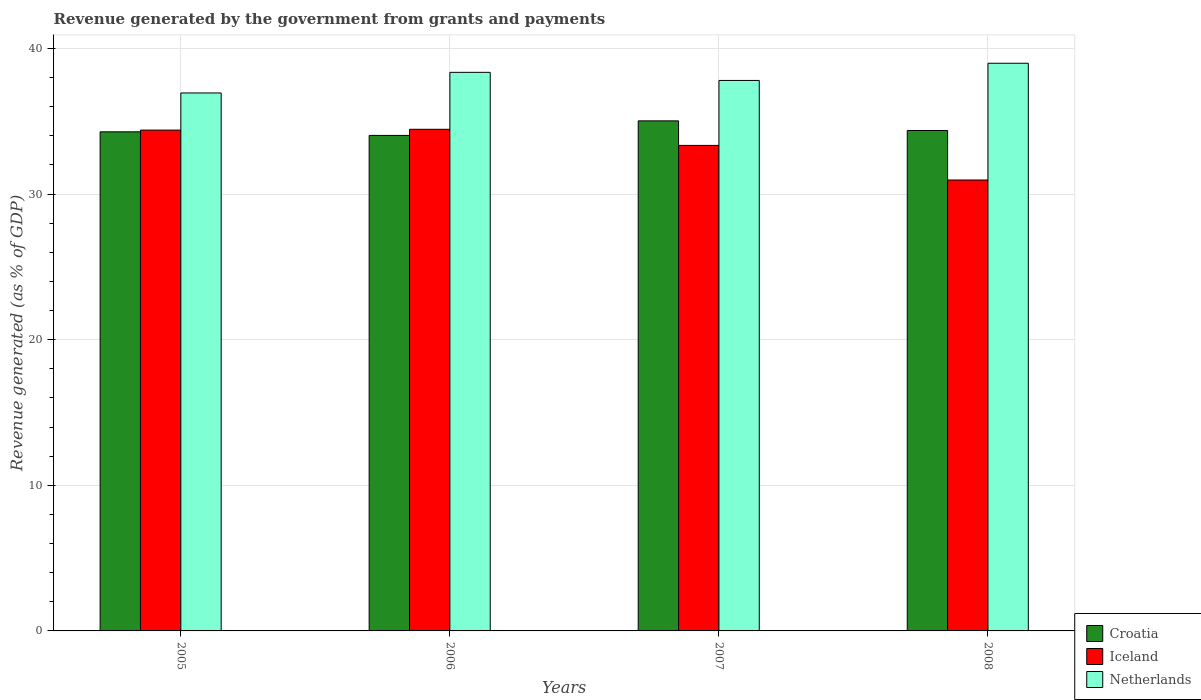How many groups of bars are there?
Offer a very short reply. 4. Are the number of bars per tick equal to the number of legend labels?
Provide a short and direct response. Yes. Are the number of bars on each tick of the X-axis equal?
Offer a terse response. Yes. How many bars are there on the 1st tick from the left?
Your response must be concise. 3. In how many cases, is the number of bars for a given year not equal to the number of legend labels?
Give a very brief answer. 0. What is the revenue generated by the government in Iceland in 2005?
Provide a succinct answer. 34.4. Across all years, what is the maximum revenue generated by the government in Netherlands?
Keep it short and to the point. 38.99. Across all years, what is the minimum revenue generated by the government in Iceland?
Offer a terse response. 30.97. In which year was the revenue generated by the government in Croatia minimum?
Give a very brief answer. 2006. What is the total revenue generated by the government in Croatia in the graph?
Offer a terse response. 137.71. What is the difference between the revenue generated by the government in Netherlands in 2006 and that in 2007?
Your response must be concise. 0.56. What is the difference between the revenue generated by the government in Netherlands in 2007 and the revenue generated by the government in Iceland in 2006?
Your response must be concise. 3.35. What is the average revenue generated by the government in Croatia per year?
Make the answer very short. 34.43. In the year 2007, what is the difference between the revenue generated by the government in Netherlands and revenue generated by the government in Iceland?
Offer a very short reply. 4.46. What is the ratio of the revenue generated by the government in Netherlands in 2006 to that in 2008?
Your answer should be very brief. 0.98. What is the difference between the highest and the second highest revenue generated by the government in Netherlands?
Make the answer very short. 0.62. What is the difference between the highest and the lowest revenue generated by the government in Croatia?
Your answer should be very brief. 1. Is the sum of the revenue generated by the government in Croatia in 2006 and 2007 greater than the maximum revenue generated by the government in Netherlands across all years?
Ensure brevity in your answer.  Yes. What does the 3rd bar from the right in 2007 represents?
Provide a succinct answer. Croatia. How many bars are there?
Your answer should be compact. 12. Are all the bars in the graph horizontal?
Keep it short and to the point. No. How many years are there in the graph?
Provide a succinct answer. 4. Are the values on the major ticks of Y-axis written in scientific E-notation?
Keep it short and to the point. No. Where does the legend appear in the graph?
Your answer should be very brief. Bottom right. What is the title of the graph?
Your response must be concise. Revenue generated by the government from grants and payments. Does "Lebanon" appear as one of the legend labels in the graph?
Your response must be concise. No. What is the label or title of the Y-axis?
Keep it short and to the point. Revenue generated (as % of GDP). What is the Revenue generated (as % of GDP) of Croatia in 2005?
Provide a succinct answer. 34.28. What is the Revenue generated (as % of GDP) of Iceland in 2005?
Give a very brief answer. 34.4. What is the Revenue generated (as % of GDP) in Netherlands in 2005?
Keep it short and to the point. 36.95. What is the Revenue generated (as % of GDP) in Croatia in 2006?
Give a very brief answer. 34.03. What is the Revenue generated (as % of GDP) in Iceland in 2006?
Provide a short and direct response. 34.45. What is the Revenue generated (as % of GDP) of Netherlands in 2006?
Give a very brief answer. 38.36. What is the Revenue generated (as % of GDP) in Croatia in 2007?
Your response must be concise. 35.03. What is the Revenue generated (as % of GDP) in Iceland in 2007?
Offer a very short reply. 33.34. What is the Revenue generated (as % of GDP) of Netherlands in 2007?
Offer a very short reply. 37.81. What is the Revenue generated (as % of GDP) of Croatia in 2008?
Offer a terse response. 34.37. What is the Revenue generated (as % of GDP) in Iceland in 2008?
Offer a very short reply. 30.97. What is the Revenue generated (as % of GDP) of Netherlands in 2008?
Provide a succinct answer. 38.99. Across all years, what is the maximum Revenue generated (as % of GDP) of Croatia?
Provide a succinct answer. 35.03. Across all years, what is the maximum Revenue generated (as % of GDP) in Iceland?
Your response must be concise. 34.45. Across all years, what is the maximum Revenue generated (as % of GDP) in Netherlands?
Offer a very short reply. 38.99. Across all years, what is the minimum Revenue generated (as % of GDP) of Croatia?
Provide a succinct answer. 34.03. Across all years, what is the minimum Revenue generated (as % of GDP) in Iceland?
Make the answer very short. 30.97. Across all years, what is the minimum Revenue generated (as % of GDP) of Netherlands?
Ensure brevity in your answer.  36.95. What is the total Revenue generated (as % of GDP) of Croatia in the graph?
Your response must be concise. 137.71. What is the total Revenue generated (as % of GDP) in Iceland in the graph?
Your response must be concise. 133.16. What is the total Revenue generated (as % of GDP) in Netherlands in the graph?
Keep it short and to the point. 152.1. What is the difference between the Revenue generated (as % of GDP) in Croatia in 2005 and that in 2006?
Offer a very short reply. 0.25. What is the difference between the Revenue generated (as % of GDP) of Iceland in 2005 and that in 2006?
Make the answer very short. -0.06. What is the difference between the Revenue generated (as % of GDP) of Netherlands in 2005 and that in 2006?
Keep it short and to the point. -1.42. What is the difference between the Revenue generated (as % of GDP) of Croatia in 2005 and that in 2007?
Your response must be concise. -0.75. What is the difference between the Revenue generated (as % of GDP) of Iceland in 2005 and that in 2007?
Offer a very short reply. 1.05. What is the difference between the Revenue generated (as % of GDP) in Netherlands in 2005 and that in 2007?
Make the answer very short. -0.86. What is the difference between the Revenue generated (as % of GDP) of Croatia in 2005 and that in 2008?
Ensure brevity in your answer.  -0.09. What is the difference between the Revenue generated (as % of GDP) in Iceland in 2005 and that in 2008?
Your answer should be compact. 3.43. What is the difference between the Revenue generated (as % of GDP) in Netherlands in 2005 and that in 2008?
Offer a very short reply. -2.04. What is the difference between the Revenue generated (as % of GDP) in Croatia in 2006 and that in 2007?
Offer a very short reply. -1. What is the difference between the Revenue generated (as % of GDP) of Iceland in 2006 and that in 2007?
Your answer should be very brief. 1.11. What is the difference between the Revenue generated (as % of GDP) in Netherlands in 2006 and that in 2007?
Your answer should be compact. 0.56. What is the difference between the Revenue generated (as % of GDP) in Croatia in 2006 and that in 2008?
Provide a succinct answer. -0.34. What is the difference between the Revenue generated (as % of GDP) of Iceland in 2006 and that in 2008?
Provide a short and direct response. 3.48. What is the difference between the Revenue generated (as % of GDP) of Netherlands in 2006 and that in 2008?
Your answer should be compact. -0.62. What is the difference between the Revenue generated (as % of GDP) in Croatia in 2007 and that in 2008?
Provide a succinct answer. 0.66. What is the difference between the Revenue generated (as % of GDP) of Iceland in 2007 and that in 2008?
Give a very brief answer. 2.38. What is the difference between the Revenue generated (as % of GDP) in Netherlands in 2007 and that in 2008?
Provide a short and direct response. -1.18. What is the difference between the Revenue generated (as % of GDP) in Croatia in 2005 and the Revenue generated (as % of GDP) in Iceland in 2006?
Provide a short and direct response. -0.17. What is the difference between the Revenue generated (as % of GDP) of Croatia in 2005 and the Revenue generated (as % of GDP) of Netherlands in 2006?
Your response must be concise. -4.09. What is the difference between the Revenue generated (as % of GDP) of Iceland in 2005 and the Revenue generated (as % of GDP) of Netherlands in 2006?
Your response must be concise. -3.97. What is the difference between the Revenue generated (as % of GDP) in Croatia in 2005 and the Revenue generated (as % of GDP) in Iceland in 2007?
Provide a short and direct response. 0.93. What is the difference between the Revenue generated (as % of GDP) in Croatia in 2005 and the Revenue generated (as % of GDP) in Netherlands in 2007?
Give a very brief answer. -3.53. What is the difference between the Revenue generated (as % of GDP) of Iceland in 2005 and the Revenue generated (as % of GDP) of Netherlands in 2007?
Your answer should be compact. -3.41. What is the difference between the Revenue generated (as % of GDP) of Croatia in 2005 and the Revenue generated (as % of GDP) of Iceland in 2008?
Give a very brief answer. 3.31. What is the difference between the Revenue generated (as % of GDP) of Croatia in 2005 and the Revenue generated (as % of GDP) of Netherlands in 2008?
Ensure brevity in your answer.  -4.71. What is the difference between the Revenue generated (as % of GDP) in Iceland in 2005 and the Revenue generated (as % of GDP) in Netherlands in 2008?
Your response must be concise. -4.59. What is the difference between the Revenue generated (as % of GDP) in Croatia in 2006 and the Revenue generated (as % of GDP) in Iceland in 2007?
Provide a succinct answer. 0.69. What is the difference between the Revenue generated (as % of GDP) of Croatia in 2006 and the Revenue generated (as % of GDP) of Netherlands in 2007?
Your answer should be compact. -3.78. What is the difference between the Revenue generated (as % of GDP) of Iceland in 2006 and the Revenue generated (as % of GDP) of Netherlands in 2007?
Your response must be concise. -3.35. What is the difference between the Revenue generated (as % of GDP) in Croatia in 2006 and the Revenue generated (as % of GDP) in Iceland in 2008?
Your answer should be compact. 3.06. What is the difference between the Revenue generated (as % of GDP) of Croatia in 2006 and the Revenue generated (as % of GDP) of Netherlands in 2008?
Your answer should be very brief. -4.96. What is the difference between the Revenue generated (as % of GDP) of Iceland in 2006 and the Revenue generated (as % of GDP) of Netherlands in 2008?
Keep it short and to the point. -4.53. What is the difference between the Revenue generated (as % of GDP) of Croatia in 2007 and the Revenue generated (as % of GDP) of Iceland in 2008?
Offer a terse response. 4.06. What is the difference between the Revenue generated (as % of GDP) of Croatia in 2007 and the Revenue generated (as % of GDP) of Netherlands in 2008?
Give a very brief answer. -3.96. What is the difference between the Revenue generated (as % of GDP) in Iceland in 2007 and the Revenue generated (as % of GDP) in Netherlands in 2008?
Your answer should be compact. -5.64. What is the average Revenue generated (as % of GDP) of Croatia per year?
Offer a very short reply. 34.43. What is the average Revenue generated (as % of GDP) in Iceland per year?
Give a very brief answer. 33.29. What is the average Revenue generated (as % of GDP) of Netherlands per year?
Keep it short and to the point. 38.03. In the year 2005, what is the difference between the Revenue generated (as % of GDP) of Croatia and Revenue generated (as % of GDP) of Iceland?
Ensure brevity in your answer.  -0.12. In the year 2005, what is the difference between the Revenue generated (as % of GDP) of Croatia and Revenue generated (as % of GDP) of Netherlands?
Offer a terse response. -2.67. In the year 2005, what is the difference between the Revenue generated (as % of GDP) of Iceland and Revenue generated (as % of GDP) of Netherlands?
Ensure brevity in your answer.  -2.55. In the year 2006, what is the difference between the Revenue generated (as % of GDP) of Croatia and Revenue generated (as % of GDP) of Iceland?
Offer a terse response. -0.42. In the year 2006, what is the difference between the Revenue generated (as % of GDP) in Croatia and Revenue generated (as % of GDP) in Netherlands?
Provide a succinct answer. -4.33. In the year 2006, what is the difference between the Revenue generated (as % of GDP) of Iceland and Revenue generated (as % of GDP) of Netherlands?
Offer a terse response. -3.91. In the year 2007, what is the difference between the Revenue generated (as % of GDP) of Croatia and Revenue generated (as % of GDP) of Iceland?
Offer a terse response. 1.69. In the year 2007, what is the difference between the Revenue generated (as % of GDP) in Croatia and Revenue generated (as % of GDP) in Netherlands?
Your answer should be compact. -2.78. In the year 2007, what is the difference between the Revenue generated (as % of GDP) in Iceland and Revenue generated (as % of GDP) in Netherlands?
Your response must be concise. -4.46. In the year 2008, what is the difference between the Revenue generated (as % of GDP) of Croatia and Revenue generated (as % of GDP) of Iceland?
Give a very brief answer. 3.4. In the year 2008, what is the difference between the Revenue generated (as % of GDP) of Croatia and Revenue generated (as % of GDP) of Netherlands?
Keep it short and to the point. -4.62. In the year 2008, what is the difference between the Revenue generated (as % of GDP) of Iceland and Revenue generated (as % of GDP) of Netherlands?
Offer a terse response. -8.02. What is the ratio of the Revenue generated (as % of GDP) in Croatia in 2005 to that in 2006?
Your answer should be very brief. 1.01. What is the ratio of the Revenue generated (as % of GDP) of Netherlands in 2005 to that in 2006?
Offer a very short reply. 0.96. What is the ratio of the Revenue generated (as % of GDP) in Croatia in 2005 to that in 2007?
Your answer should be very brief. 0.98. What is the ratio of the Revenue generated (as % of GDP) of Iceland in 2005 to that in 2007?
Provide a succinct answer. 1.03. What is the ratio of the Revenue generated (as % of GDP) in Netherlands in 2005 to that in 2007?
Your answer should be compact. 0.98. What is the ratio of the Revenue generated (as % of GDP) in Croatia in 2005 to that in 2008?
Your answer should be very brief. 1. What is the ratio of the Revenue generated (as % of GDP) in Iceland in 2005 to that in 2008?
Ensure brevity in your answer.  1.11. What is the ratio of the Revenue generated (as % of GDP) of Netherlands in 2005 to that in 2008?
Give a very brief answer. 0.95. What is the ratio of the Revenue generated (as % of GDP) of Croatia in 2006 to that in 2007?
Your answer should be compact. 0.97. What is the ratio of the Revenue generated (as % of GDP) of Iceland in 2006 to that in 2007?
Your answer should be compact. 1.03. What is the ratio of the Revenue generated (as % of GDP) of Netherlands in 2006 to that in 2007?
Ensure brevity in your answer.  1.01. What is the ratio of the Revenue generated (as % of GDP) in Croatia in 2006 to that in 2008?
Give a very brief answer. 0.99. What is the ratio of the Revenue generated (as % of GDP) in Iceland in 2006 to that in 2008?
Ensure brevity in your answer.  1.11. What is the ratio of the Revenue generated (as % of GDP) in Croatia in 2007 to that in 2008?
Provide a succinct answer. 1.02. What is the ratio of the Revenue generated (as % of GDP) of Iceland in 2007 to that in 2008?
Offer a terse response. 1.08. What is the ratio of the Revenue generated (as % of GDP) of Netherlands in 2007 to that in 2008?
Keep it short and to the point. 0.97. What is the difference between the highest and the second highest Revenue generated (as % of GDP) of Croatia?
Your answer should be very brief. 0.66. What is the difference between the highest and the second highest Revenue generated (as % of GDP) in Iceland?
Offer a terse response. 0.06. What is the difference between the highest and the second highest Revenue generated (as % of GDP) in Netherlands?
Offer a terse response. 0.62. What is the difference between the highest and the lowest Revenue generated (as % of GDP) in Croatia?
Provide a succinct answer. 1. What is the difference between the highest and the lowest Revenue generated (as % of GDP) of Iceland?
Your answer should be compact. 3.48. What is the difference between the highest and the lowest Revenue generated (as % of GDP) of Netherlands?
Provide a short and direct response. 2.04. 